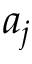Convert formula to latex. <formula><loc_0><loc_0><loc_500><loc_500>a _ { j }</formula> 